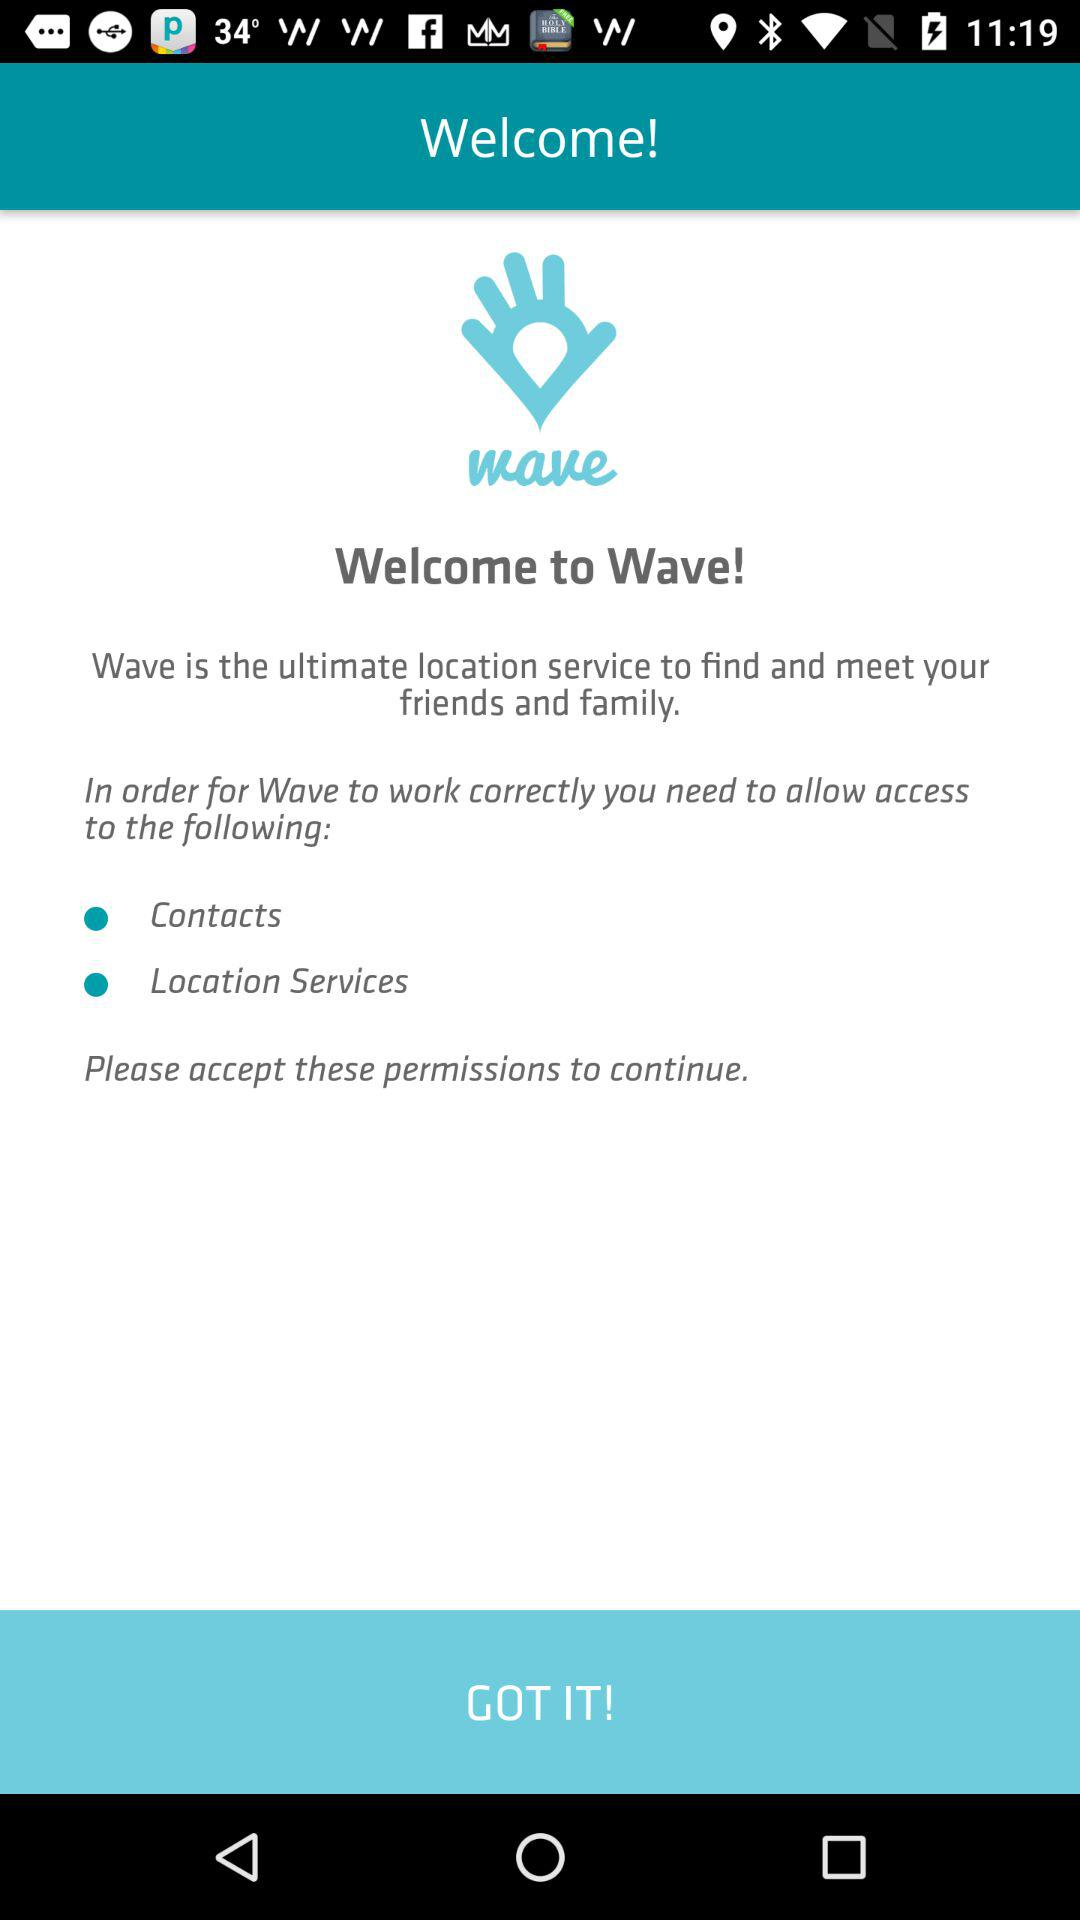What access has to be granted by the user in order for the "Wave" application to work correctly? The user has to grant access to "Contacts" and "Location Services" in order for the "Wave" application to work correctly. 